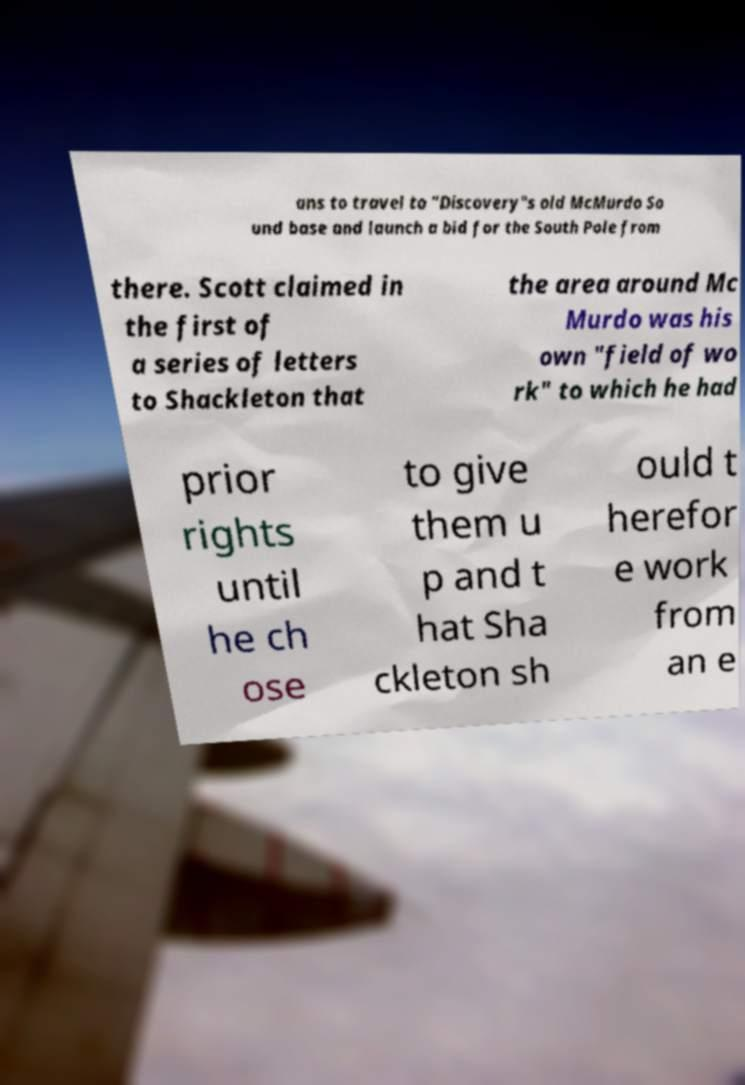For documentation purposes, I need the text within this image transcribed. Could you provide that? ans to travel to "Discovery"s old McMurdo So und base and launch a bid for the South Pole from there. Scott claimed in the first of a series of letters to Shackleton that the area around Mc Murdo was his own "field of wo rk" to which he had prior rights until he ch ose to give them u p and t hat Sha ckleton sh ould t herefor e work from an e 